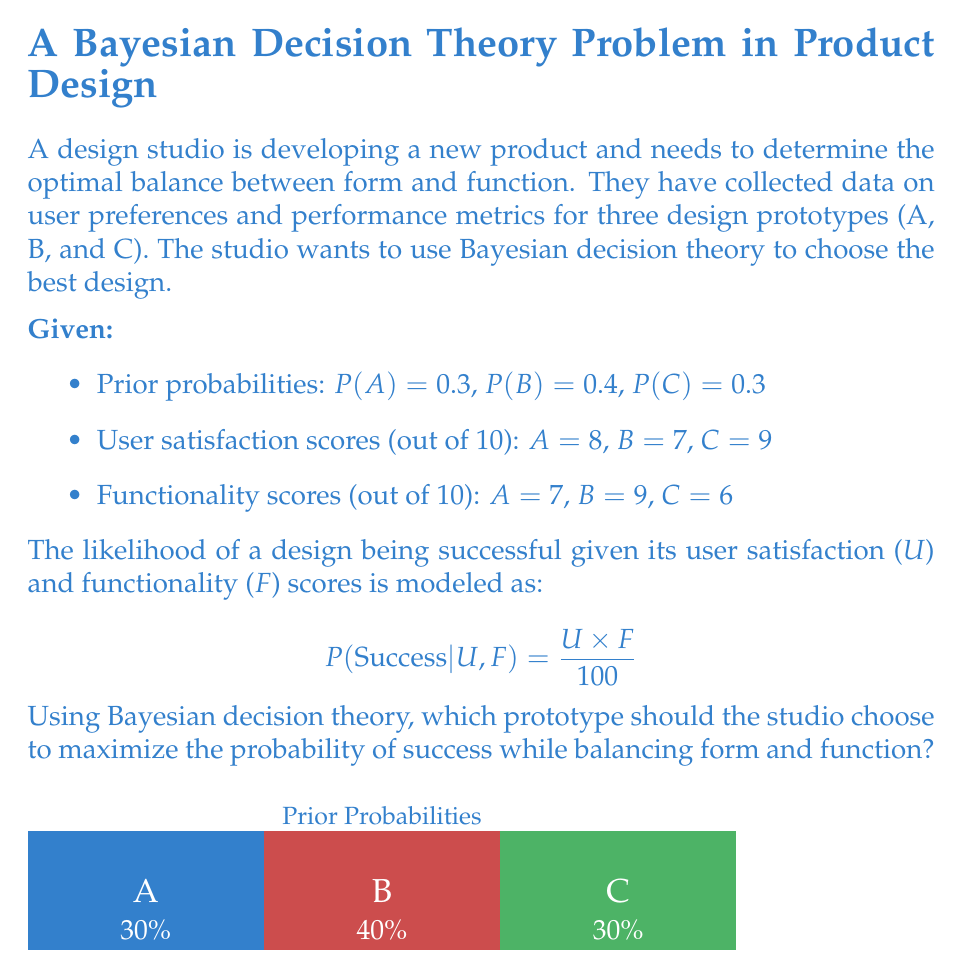Help me with this question. To solve this problem using Bayesian decision theory, we need to calculate the posterior probability of success for each prototype and choose the one with the highest probability. We'll use Bayes' theorem:

$$ P(Success|Design) = \frac{P(Design|Success) \times P(Success)}{P(Design)} $$

Step 1: Calculate the likelihood of success for each prototype using the given formula.

Prototype A: $P(Success|A) = \frac{8 \times 7}{100} = 0.56$
Prototype B: $P(Success|B) = \frac{7 \times 9}{100} = 0.63$
Prototype C: $P(Success|C) = \frac{9 \times 6}{100} = 0.54$

Step 2: Calculate the posterior probability of success for each prototype using Bayes' theorem.

For Prototype A:
$P(Success|A) = \frac{0.56 \times 0.3}{0.3} = 0.56$

For Prototype B:
$P(Success|B) = \frac{0.63 \times 0.4}{0.4} = 0.63$

For Prototype C:
$P(Success|C) = \frac{0.54 \times 0.3}{0.3} = 0.54$

Step 3: Compare the posterior probabilities.

Prototype A: 0.56
Prototype B: 0.63
Prototype C: 0.54

Step 4: Choose the prototype with the highest posterior probability of success.

Prototype B has the highest posterior probability of success at 0.63, balancing form (user satisfaction) and function (functionality) optimally according to the given model.
Answer: Prototype B 